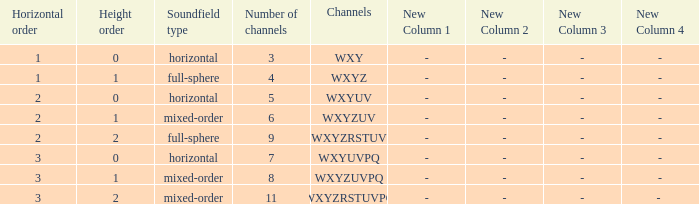If the height order is 1 and the soundfield type is mixed-order, what are all the channels? WXYZUV, WXYZUVPQ. Can you parse all the data within this table? {'header': ['Horizontal order', 'Height order', 'Soundfield type', 'Number of channels', 'Channels', 'New Column 1', 'New Column 2', 'New Column 3', 'New Column 4'], 'rows': [['1', '0', 'horizontal', '3', 'WXY', '-', '-', '-', '-'], ['1', '1', 'full-sphere', '4', 'WXYZ', '-', '-', '-', '-'], ['2', '0', 'horizontal', '5', 'WXYUV', '-', '-', '-', '-'], ['2', '1', 'mixed-order', '6', 'WXYZUV', '-', '-', '-', '-'], ['2', '2', 'full-sphere', '9', 'WXYZRSTUV', '-', '-', '-', '-'], ['3', '0', 'horizontal', '7', 'WXYUVPQ', '-', '-', '-', '-'], ['3', '1', 'mixed-order', '8', 'WXYZUVPQ', '-', '-', '-', '-'], ['3', '2', 'mixed-order', '11', 'WXYZRSTUVPQ', '-', '-', '-', '- ']]} 